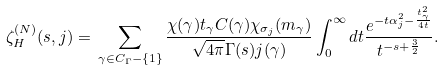Convert formula to latex. <formula><loc_0><loc_0><loc_500><loc_500>\zeta _ { H } ^ { ( N ) } ( s , j ) = \, \sum _ { \gamma \in C _ { \Gamma } - \{ 1 \} } \frac { \chi ( \gamma ) t _ { \gamma } C ( \gamma ) \chi _ { \sigma _ { j } } ( m _ { \gamma } ) } { \sqrt { 4 \pi } \Gamma ( s ) j ( \gamma ) } \int _ { 0 } ^ { \infty } d t \frac { e ^ { - t \alpha _ { j } ^ { 2 } - \frac { t _ { \gamma } ^ { 2 } } { 4 t } } } { t ^ { - s + \frac { 3 } { 2 } } } .</formula> 